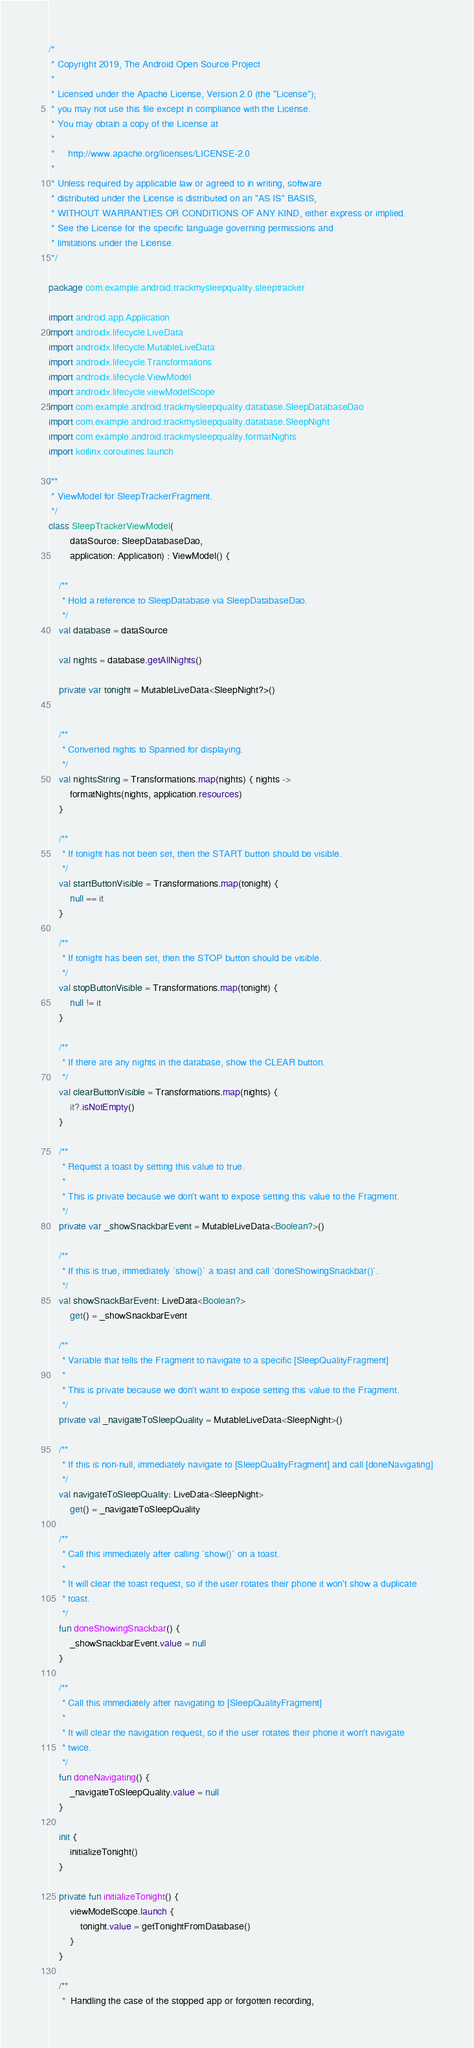Convert code to text. <code><loc_0><loc_0><loc_500><loc_500><_Kotlin_>/*
 * Copyright 2019, The Android Open Source Project
 *
 * Licensed under the Apache License, Version 2.0 (the "License");
 * you may not use this file except in compliance with the License.
 * You may obtain a copy of the License at
 *
 *     http://www.apache.org/licenses/LICENSE-2.0
 *
 * Unless required by applicable law or agreed to in writing, software
 * distributed under the License is distributed on an "AS IS" BASIS,
 * WITHOUT WARRANTIES OR CONDITIONS OF ANY KIND, either express or implied.
 * See the License for the specific language governing permissions and
 * limitations under the License.
 */

package com.example.android.trackmysleepquality.sleeptracker

import android.app.Application
import androidx.lifecycle.LiveData
import androidx.lifecycle.MutableLiveData
import androidx.lifecycle.Transformations
import androidx.lifecycle.ViewModel
import androidx.lifecycle.viewModelScope
import com.example.android.trackmysleepquality.database.SleepDatabaseDao
import com.example.android.trackmysleepquality.database.SleepNight
import com.example.android.trackmysleepquality.formatNights
import kotlinx.coroutines.launch

/**
 * ViewModel for SleepTrackerFragment.
 */
class SleepTrackerViewModel(
        dataSource: SleepDatabaseDao,
        application: Application) : ViewModel() {

    /**
     * Hold a reference to SleepDatabase via SleepDatabaseDao.
     */
    val database = dataSource

    val nights = database.getAllNights()

    private var tonight = MutableLiveData<SleepNight?>()


    /**
     * Converted nights to Spanned for displaying.
     */
    val nightsString = Transformations.map(nights) { nights ->
        formatNights(nights, application.resources)
    }

    /**
     * If tonight has not been set, then the START button should be visible.
     */
    val startButtonVisible = Transformations.map(tonight) {
        null == it
    }

    /**
     * If tonight has been set, then the STOP button should be visible.
     */
    val stopButtonVisible = Transformations.map(tonight) {
        null != it
    }

    /**
     * If there are any nights in the database, show the CLEAR button.
     */
    val clearButtonVisible = Transformations.map(nights) {
        it?.isNotEmpty()
    }

    /**
     * Request a toast by setting this value to true.
     *
     * This is private because we don't want to expose setting this value to the Fragment.
     */
    private var _showSnackbarEvent = MutableLiveData<Boolean?>()

    /**
     * If this is true, immediately `show()` a toast and call `doneShowingSnackbar()`.
     */
    val showSnackBarEvent: LiveData<Boolean?>
        get() = _showSnackbarEvent

    /**
     * Variable that tells the Fragment to navigate to a specific [SleepQualityFragment]
     *
     * This is private because we don't want to expose setting this value to the Fragment.
     */
    private val _navigateToSleepQuality = MutableLiveData<SleepNight>()

    /**
     * If this is non-null, immediately navigate to [SleepQualityFragment] and call [doneNavigating]
     */
    val navigateToSleepQuality: LiveData<SleepNight>
        get() = _navigateToSleepQuality

    /**
     * Call this immediately after calling `show()` on a toast.
     *
     * It will clear the toast request, so if the user rotates their phone it won't show a duplicate
     * toast.
     */
    fun doneShowingSnackbar() {
        _showSnackbarEvent.value = null
    }

    /**
     * Call this immediately after navigating to [SleepQualityFragment]
     *
     * It will clear the navigation request, so if the user rotates their phone it won't navigate
     * twice.
     */
    fun doneNavigating() {
        _navigateToSleepQuality.value = null
    }

    init {
        initializeTonight()
    }

    private fun initializeTonight() {
        viewModelScope.launch {
            tonight.value = getTonightFromDatabase()
        }
    }

    /**
     *  Handling the case of the stopped app or forgotten recording,</code> 